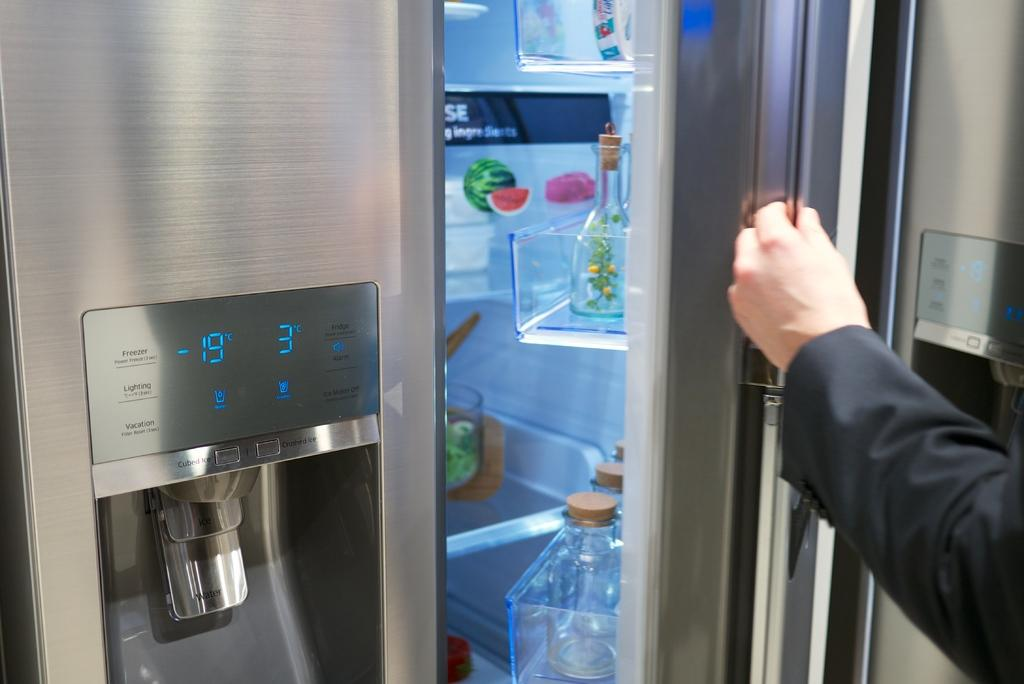<image>
Share a concise interpretation of the image provided. an open fridge that has the freezer temperature set to -19 degrees 